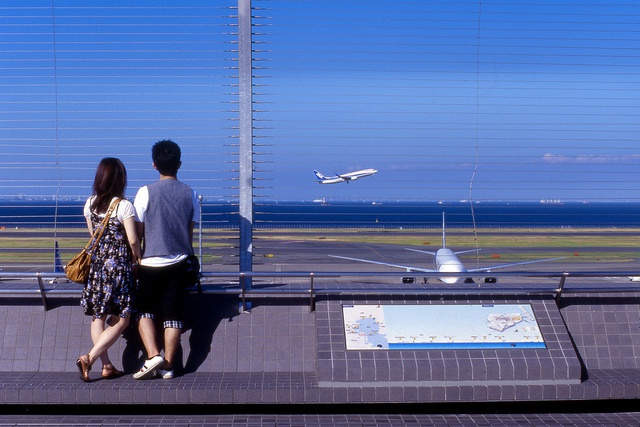Describe the objects in this image and their specific colors. I can see people in blue, black, gray, navy, and white tones, people in blue, black, lightgray, maroon, and gray tones, airplane in blue, gray, darkgray, and lavender tones, handbag in blue, black, brown, maroon, and gray tones, and airplane in blue, lavender, darkgray, and purple tones in this image. 